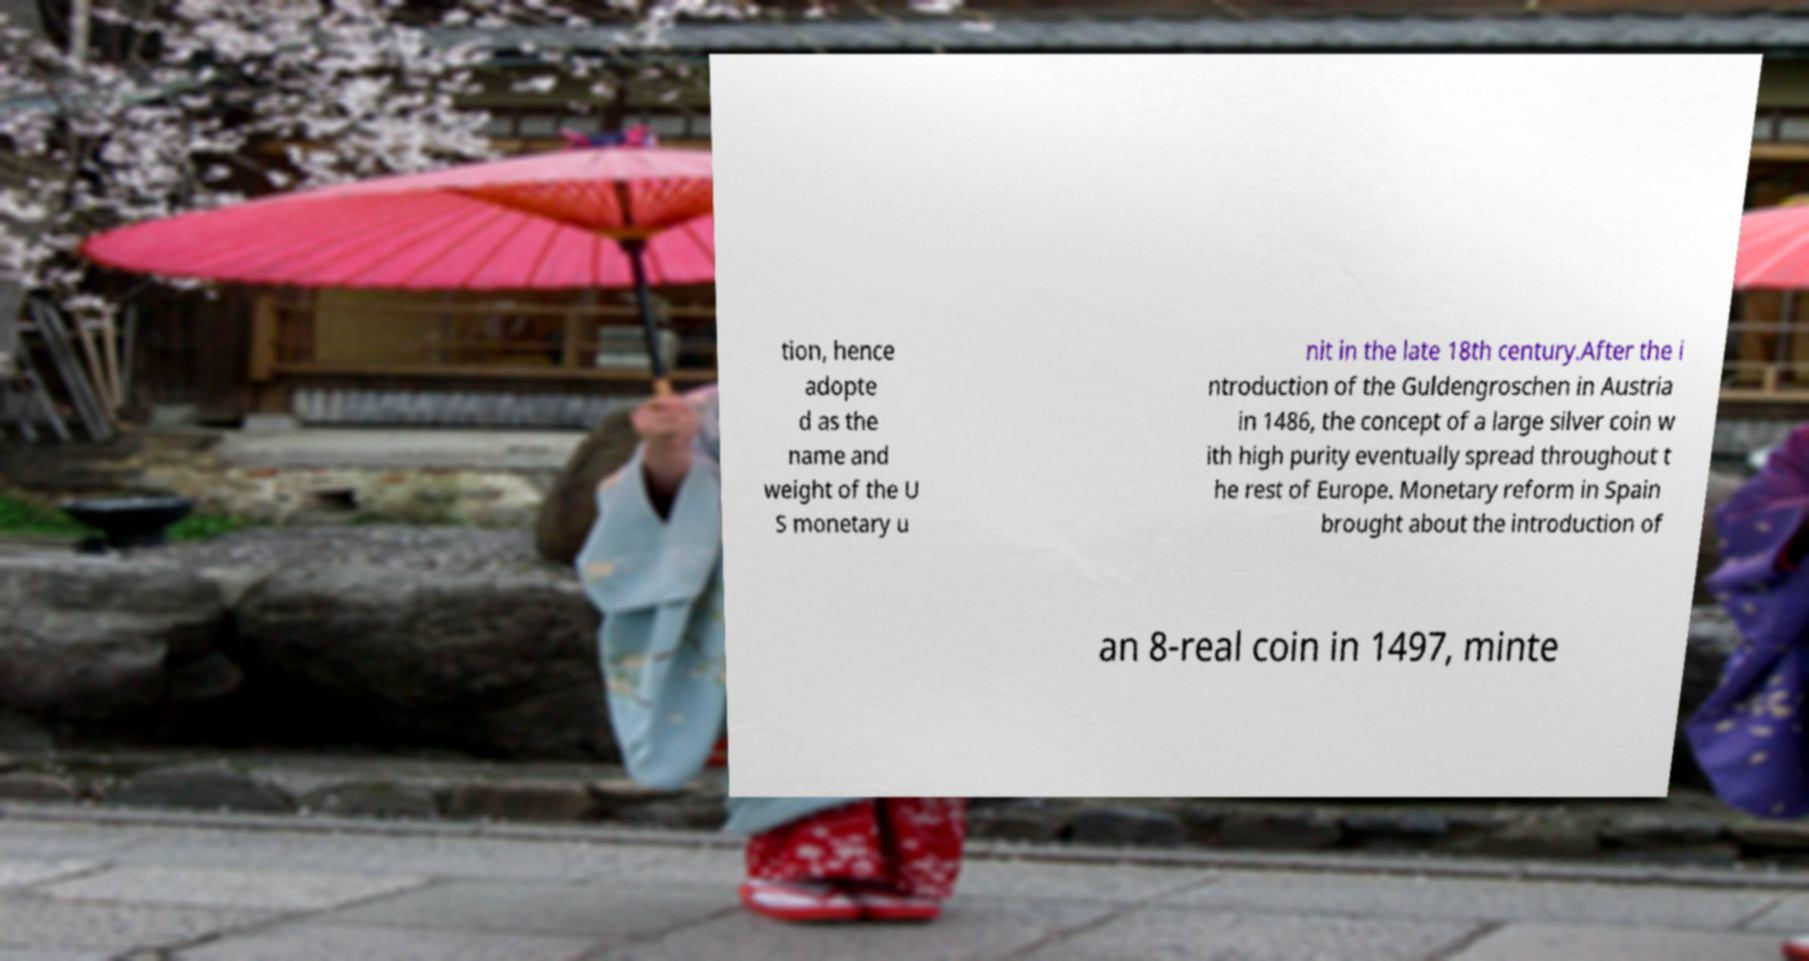Please read and relay the text visible in this image. What does it say? tion, hence adopte d as the name and weight of the U S monetary u nit in the late 18th century.After the i ntroduction of the Guldengroschen in Austria in 1486, the concept of a large silver coin w ith high purity eventually spread throughout t he rest of Europe. Monetary reform in Spain brought about the introduction of an 8-real coin in 1497, minte 